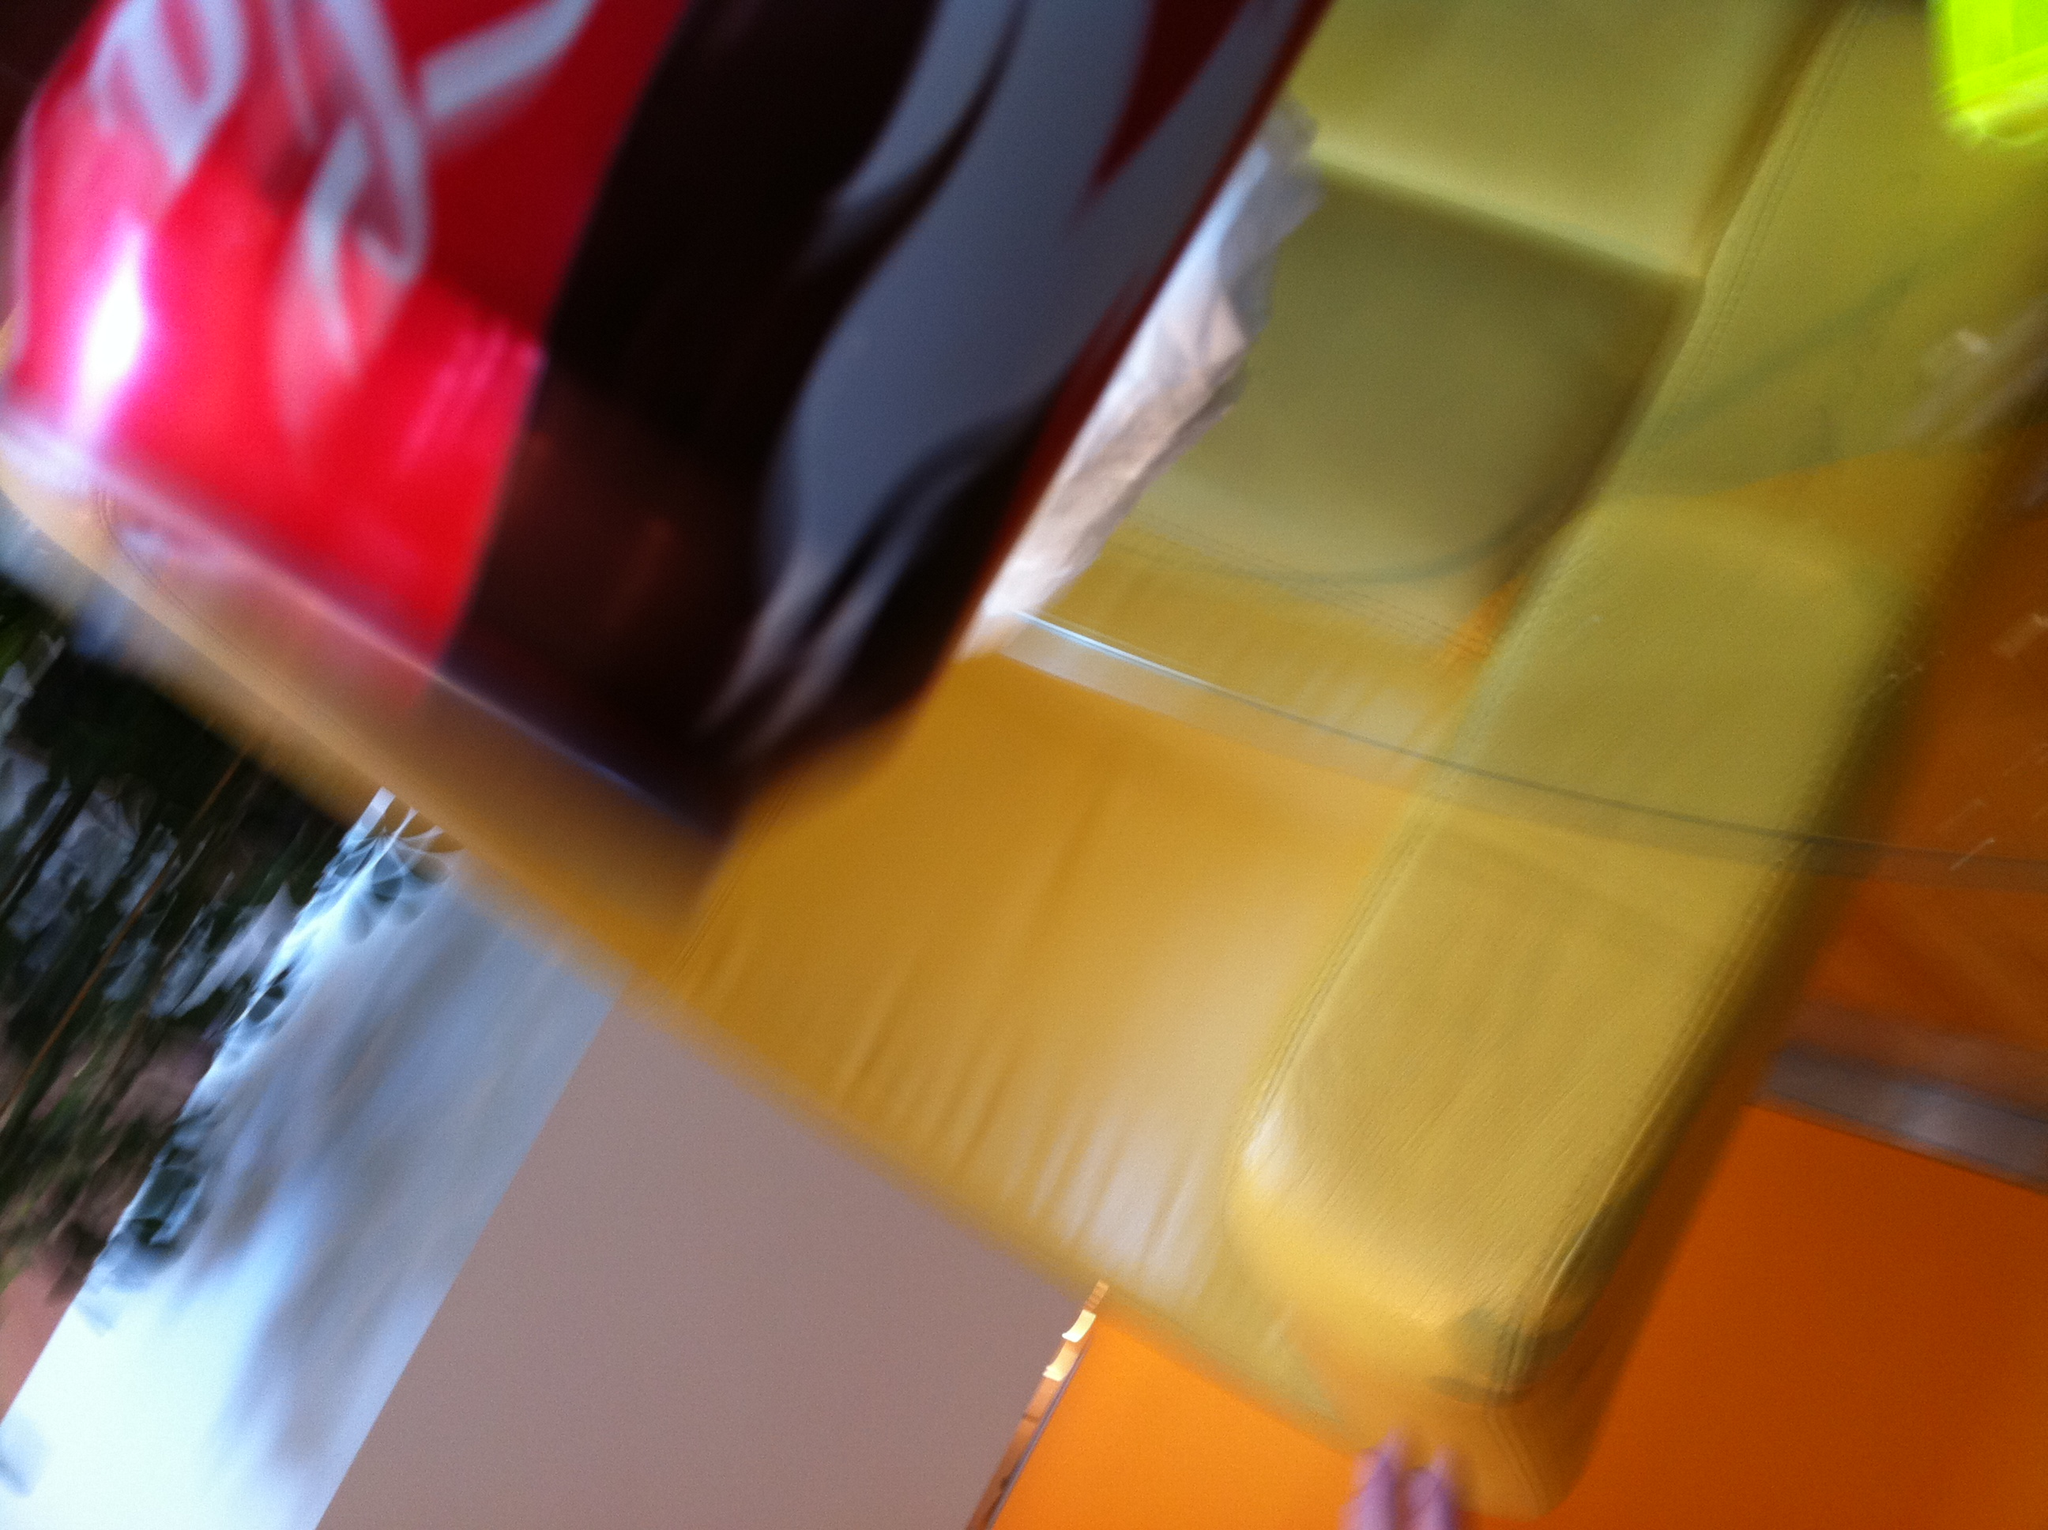What does the motion effect in the photo suggest? The blur shown in the photo suggests a quick, dynamic moment, possibly captured while the camera or subject was moving. This effect creates a feeling of action and spontaneity in the snapshot. Could the blurriness affect how we perceive the image? Absolutely, the blurriness affects perception by obscuring details and creating a sense of movement or instability. It can also evoke emotions or feelings associated with haste and brisk moments. 